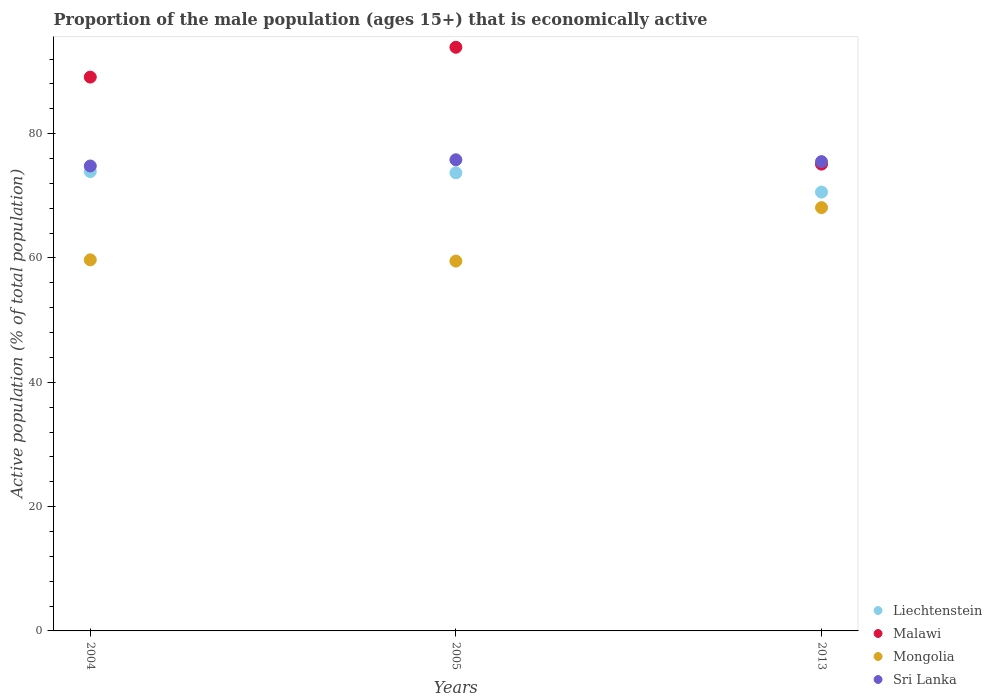What is the proportion of the male population that is economically active in Liechtenstein in 2004?
Offer a very short reply. 73.9. Across all years, what is the maximum proportion of the male population that is economically active in Malawi?
Give a very brief answer. 93.9. Across all years, what is the minimum proportion of the male population that is economically active in Liechtenstein?
Your answer should be very brief. 70.6. In which year was the proportion of the male population that is economically active in Sri Lanka minimum?
Make the answer very short. 2004. What is the total proportion of the male population that is economically active in Sri Lanka in the graph?
Keep it short and to the point. 226.1. What is the difference between the proportion of the male population that is economically active in Malawi in 2005 and that in 2013?
Your answer should be compact. 18.8. What is the difference between the proportion of the male population that is economically active in Liechtenstein in 2004 and the proportion of the male population that is economically active in Sri Lanka in 2005?
Ensure brevity in your answer.  -1.9. What is the average proportion of the male population that is economically active in Liechtenstein per year?
Provide a short and direct response. 72.73. In the year 2005, what is the difference between the proportion of the male population that is economically active in Malawi and proportion of the male population that is economically active in Mongolia?
Your answer should be very brief. 34.4. What is the ratio of the proportion of the male population that is economically active in Malawi in 2004 to that in 2005?
Your answer should be very brief. 0.95. Is the proportion of the male population that is economically active in Liechtenstein in 2004 less than that in 2013?
Give a very brief answer. No. What is the difference between the highest and the second highest proportion of the male population that is economically active in Malawi?
Your answer should be very brief. 4.8. What is the difference between the highest and the lowest proportion of the male population that is economically active in Liechtenstein?
Your response must be concise. 3.3. In how many years, is the proportion of the male population that is economically active in Sri Lanka greater than the average proportion of the male population that is economically active in Sri Lanka taken over all years?
Make the answer very short. 2. Is the sum of the proportion of the male population that is economically active in Malawi in 2004 and 2013 greater than the maximum proportion of the male population that is economically active in Sri Lanka across all years?
Give a very brief answer. Yes. Is it the case that in every year, the sum of the proportion of the male population that is economically active in Malawi and proportion of the male population that is economically active in Liechtenstein  is greater than the sum of proportion of the male population that is economically active in Mongolia and proportion of the male population that is economically active in Sri Lanka?
Your answer should be very brief. Yes. Does the proportion of the male population that is economically active in Sri Lanka monotonically increase over the years?
Your answer should be compact. No. Is the proportion of the male population that is economically active in Liechtenstein strictly greater than the proportion of the male population that is economically active in Malawi over the years?
Offer a terse response. No. How many dotlines are there?
Ensure brevity in your answer.  4. How many years are there in the graph?
Your response must be concise. 3. Are the values on the major ticks of Y-axis written in scientific E-notation?
Provide a short and direct response. No. What is the title of the graph?
Provide a short and direct response. Proportion of the male population (ages 15+) that is economically active. Does "Egypt, Arab Rep." appear as one of the legend labels in the graph?
Ensure brevity in your answer.  No. What is the label or title of the Y-axis?
Give a very brief answer. Active population (% of total population). What is the Active population (% of total population) of Liechtenstein in 2004?
Keep it short and to the point. 73.9. What is the Active population (% of total population) of Malawi in 2004?
Your answer should be compact. 89.1. What is the Active population (% of total population) in Mongolia in 2004?
Keep it short and to the point. 59.7. What is the Active population (% of total population) of Sri Lanka in 2004?
Your response must be concise. 74.8. What is the Active population (% of total population) in Liechtenstein in 2005?
Offer a terse response. 73.7. What is the Active population (% of total population) in Malawi in 2005?
Make the answer very short. 93.9. What is the Active population (% of total population) of Mongolia in 2005?
Provide a short and direct response. 59.5. What is the Active population (% of total population) in Sri Lanka in 2005?
Provide a succinct answer. 75.8. What is the Active population (% of total population) of Liechtenstein in 2013?
Keep it short and to the point. 70.6. What is the Active population (% of total population) in Malawi in 2013?
Keep it short and to the point. 75.1. What is the Active population (% of total population) in Mongolia in 2013?
Ensure brevity in your answer.  68.1. What is the Active population (% of total population) of Sri Lanka in 2013?
Provide a short and direct response. 75.5. Across all years, what is the maximum Active population (% of total population) of Liechtenstein?
Make the answer very short. 73.9. Across all years, what is the maximum Active population (% of total population) in Malawi?
Ensure brevity in your answer.  93.9. Across all years, what is the maximum Active population (% of total population) of Mongolia?
Your response must be concise. 68.1. Across all years, what is the maximum Active population (% of total population) of Sri Lanka?
Offer a very short reply. 75.8. Across all years, what is the minimum Active population (% of total population) of Liechtenstein?
Your answer should be very brief. 70.6. Across all years, what is the minimum Active population (% of total population) of Malawi?
Make the answer very short. 75.1. Across all years, what is the minimum Active population (% of total population) of Mongolia?
Offer a terse response. 59.5. Across all years, what is the minimum Active population (% of total population) of Sri Lanka?
Offer a terse response. 74.8. What is the total Active population (% of total population) of Liechtenstein in the graph?
Your response must be concise. 218.2. What is the total Active population (% of total population) in Malawi in the graph?
Your answer should be compact. 258.1. What is the total Active population (% of total population) in Mongolia in the graph?
Offer a terse response. 187.3. What is the total Active population (% of total population) of Sri Lanka in the graph?
Keep it short and to the point. 226.1. What is the difference between the Active population (% of total population) in Mongolia in 2004 and that in 2005?
Make the answer very short. 0.2. What is the difference between the Active population (% of total population) of Sri Lanka in 2004 and that in 2005?
Provide a succinct answer. -1. What is the difference between the Active population (% of total population) in Mongolia in 2004 and that in 2013?
Your answer should be very brief. -8.4. What is the difference between the Active population (% of total population) in Sri Lanka in 2004 and that in 2013?
Keep it short and to the point. -0.7. What is the difference between the Active population (% of total population) of Malawi in 2005 and that in 2013?
Offer a very short reply. 18.8. What is the difference between the Active population (% of total population) in Sri Lanka in 2005 and that in 2013?
Your answer should be very brief. 0.3. What is the difference between the Active population (% of total population) of Liechtenstein in 2004 and the Active population (% of total population) of Malawi in 2005?
Provide a succinct answer. -20. What is the difference between the Active population (% of total population) of Liechtenstein in 2004 and the Active population (% of total population) of Mongolia in 2005?
Your answer should be very brief. 14.4. What is the difference between the Active population (% of total population) in Malawi in 2004 and the Active population (% of total population) in Mongolia in 2005?
Your answer should be compact. 29.6. What is the difference between the Active population (% of total population) in Mongolia in 2004 and the Active population (% of total population) in Sri Lanka in 2005?
Make the answer very short. -16.1. What is the difference between the Active population (% of total population) of Liechtenstein in 2004 and the Active population (% of total population) of Mongolia in 2013?
Make the answer very short. 5.8. What is the difference between the Active population (% of total population) in Liechtenstein in 2004 and the Active population (% of total population) in Sri Lanka in 2013?
Your response must be concise. -1.6. What is the difference between the Active population (% of total population) in Malawi in 2004 and the Active population (% of total population) in Mongolia in 2013?
Offer a terse response. 21. What is the difference between the Active population (% of total population) of Mongolia in 2004 and the Active population (% of total population) of Sri Lanka in 2013?
Give a very brief answer. -15.8. What is the difference between the Active population (% of total population) of Liechtenstein in 2005 and the Active population (% of total population) of Malawi in 2013?
Your response must be concise. -1.4. What is the difference between the Active population (% of total population) in Liechtenstein in 2005 and the Active population (% of total population) in Mongolia in 2013?
Provide a succinct answer. 5.6. What is the difference between the Active population (% of total population) of Liechtenstein in 2005 and the Active population (% of total population) of Sri Lanka in 2013?
Keep it short and to the point. -1.8. What is the difference between the Active population (% of total population) of Malawi in 2005 and the Active population (% of total population) of Mongolia in 2013?
Give a very brief answer. 25.8. What is the average Active population (% of total population) in Liechtenstein per year?
Your response must be concise. 72.73. What is the average Active population (% of total population) in Malawi per year?
Provide a short and direct response. 86.03. What is the average Active population (% of total population) of Mongolia per year?
Ensure brevity in your answer.  62.43. What is the average Active population (% of total population) of Sri Lanka per year?
Offer a very short reply. 75.37. In the year 2004, what is the difference between the Active population (% of total population) in Liechtenstein and Active population (% of total population) in Malawi?
Make the answer very short. -15.2. In the year 2004, what is the difference between the Active population (% of total population) in Liechtenstein and Active population (% of total population) in Mongolia?
Your answer should be very brief. 14.2. In the year 2004, what is the difference between the Active population (% of total population) in Malawi and Active population (% of total population) in Mongolia?
Your answer should be compact. 29.4. In the year 2004, what is the difference between the Active population (% of total population) of Malawi and Active population (% of total population) of Sri Lanka?
Ensure brevity in your answer.  14.3. In the year 2004, what is the difference between the Active population (% of total population) of Mongolia and Active population (% of total population) of Sri Lanka?
Your response must be concise. -15.1. In the year 2005, what is the difference between the Active population (% of total population) of Liechtenstein and Active population (% of total population) of Malawi?
Make the answer very short. -20.2. In the year 2005, what is the difference between the Active population (% of total population) of Liechtenstein and Active population (% of total population) of Mongolia?
Offer a terse response. 14.2. In the year 2005, what is the difference between the Active population (% of total population) in Liechtenstein and Active population (% of total population) in Sri Lanka?
Give a very brief answer. -2.1. In the year 2005, what is the difference between the Active population (% of total population) in Malawi and Active population (% of total population) in Mongolia?
Your response must be concise. 34.4. In the year 2005, what is the difference between the Active population (% of total population) in Mongolia and Active population (% of total population) in Sri Lanka?
Your answer should be very brief. -16.3. In the year 2013, what is the difference between the Active population (% of total population) in Liechtenstein and Active population (% of total population) in Malawi?
Your answer should be compact. -4.5. In the year 2013, what is the difference between the Active population (% of total population) in Liechtenstein and Active population (% of total population) in Sri Lanka?
Offer a terse response. -4.9. In the year 2013, what is the difference between the Active population (% of total population) in Malawi and Active population (% of total population) in Sri Lanka?
Offer a very short reply. -0.4. In the year 2013, what is the difference between the Active population (% of total population) of Mongolia and Active population (% of total population) of Sri Lanka?
Your answer should be very brief. -7.4. What is the ratio of the Active population (% of total population) in Liechtenstein in 2004 to that in 2005?
Give a very brief answer. 1. What is the ratio of the Active population (% of total population) in Malawi in 2004 to that in 2005?
Give a very brief answer. 0.95. What is the ratio of the Active population (% of total population) in Sri Lanka in 2004 to that in 2005?
Offer a very short reply. 0.99. What is the ratio of the Active population (% of total population) of Liechtenstein in 2004 to that in 2013?
Your answer should be very brief. 1.05. What is the ratio of the Active population (% of total population) in Malawi in 2004 to that in 2013?
Make the answer very short. 1.19. What is the ratio of the Active population (% of total population) of Mongolia in 2004 to that in 2013?
Your answer should be very brief. 0.88. What is the ratio of the Active population (% of total population) of Liechtenstein in 2005 to that in 2013?
Provide a succinct answer. 1.04. What is the ratio of the Active population (% of total population) of Malawi in 2005 to that in 2013?
Provide a succinct answer. 1.25. What is the ratio of the Active population (% of total population) in Mongolia in 2005 to that in 2013?
Offer a very short reply. 0.87. What is the difference between the highest and the second highest Active population (% of total population) of Malawi?
Offer a terse response. 4.8. What is the difference between the highest and the second highest Active population (% of total population) in Sri Lanka?
Offer a terse response. 0.3. What is the difference between the highest and the lowest Active population (% of total population) of Malawi?
Offer a terse response. 18.8. 